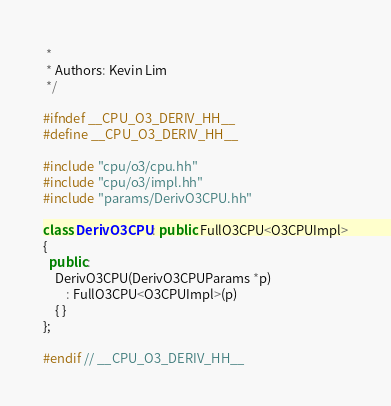<code> <loc_0><loc_0><loc_500><loc_500><_C++_> *
 * Authors: Kevin Lim
 */

#ifndef __CPU_O3_DERIV_HH__
#define __CPU_O3_DERIV_HH__

#include "cpu/o3/cpu.hh"
#include "cpu/o3/impl.hh"
#include "params/DerivO3CPU.hh"

class DerivO3CPU : public FullO3CPU<O3CPUImpl>
{
  public:
    DerivO3CPU(DerivO3CPUParams *p)
        : FullO3CPU<O3CPUImpl>(p)
    { }
};

#endif // __CPU_O3_DERIV_HH__
</code> 